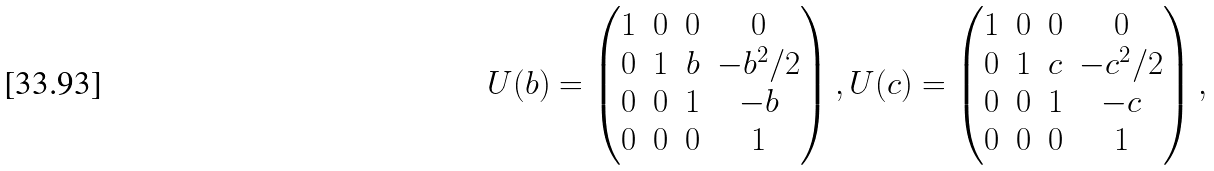<formula> <loc_0><loc_0><loc_500><loc_500>U ( b ) = \begin{pmatrix} 1 & 0 & 0 & 0 \\ 0 & 1 & b & - b ^ { 2 } / 2 \\ 0 & 0 & 1 & - b \\ 0 & 0 & 0 & 1 \end{pmatrix} , U ( c ) = \begin{pmatrix} 1 & 0 & 0 & 0 \\ 0 & 1 & c & - c ^ { 2 } / 2 \\ 0 & 0 & 1 & - c \\ 0 & 0 & 0 & 1 \end{pmatrix} ,</formula> 